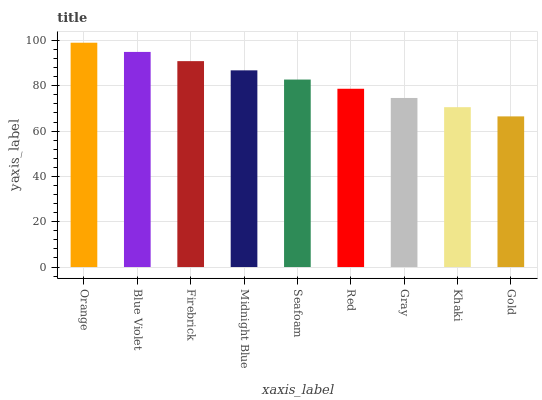Is Gold the minimum?
Answer yes or no. Yes. Is Orange the maximum?
Answer yes or no. Yes. Is Blue Violet the minimum?
Answer yes or no. No. Is Blue Violet the maximum?
Answer yes or no. No. Is Orange greater than Blue Violet?
Answer yes or no. Yes. Is Blue Violet less than Orange?
Answer yes or no. Yes. Is Blue Violet greater than Orange?
Answer yes or no. No. Is Orange less than Blue Violet?
Answer yes or no. No. Is Seafoam the high median?
Answer yes or no. Yes. Is Seafoam the low median?
Answer yes or no. Yes. Is Gray the high median?
Answer yes or no. No. Is Gold the low median?
Answer yes or no. No. 